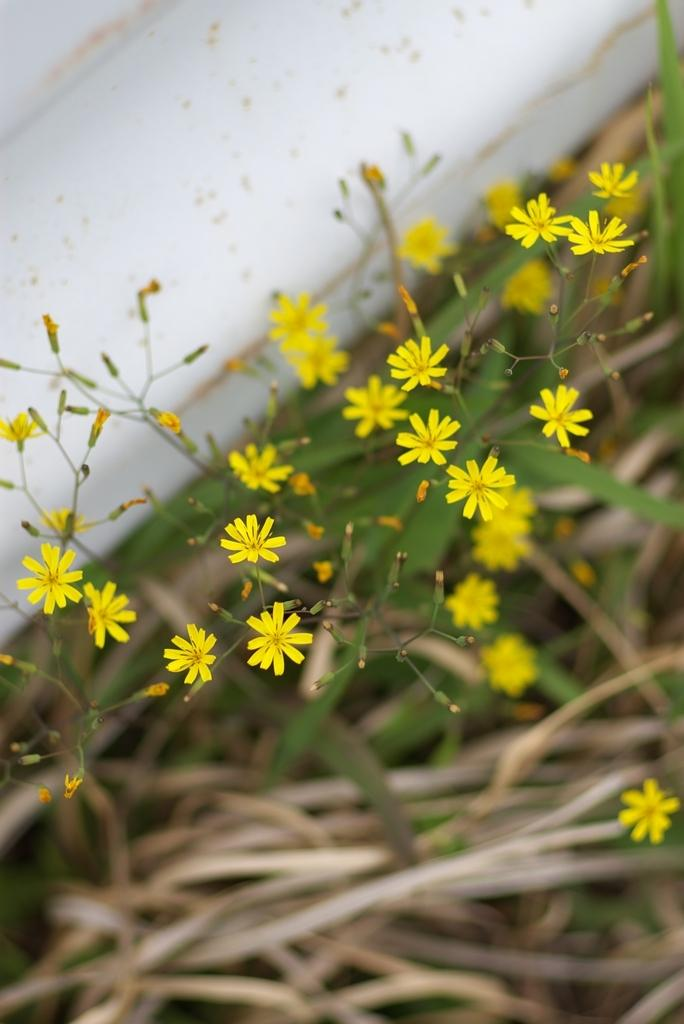What is located in the center of the image? There are flowers and leaves in the center of the image. Can you describe the flowers in the image? The provided facts do not give specific details about the flowers, so we cannot describe them further. What type of lipstick is the person wearing at the party in the image? There is no person or party present in the image; it features flowers and leaves in the center. How does the cough sound in the image? There is no cough or sound present in the image; it features flowers and leaves in the center. 